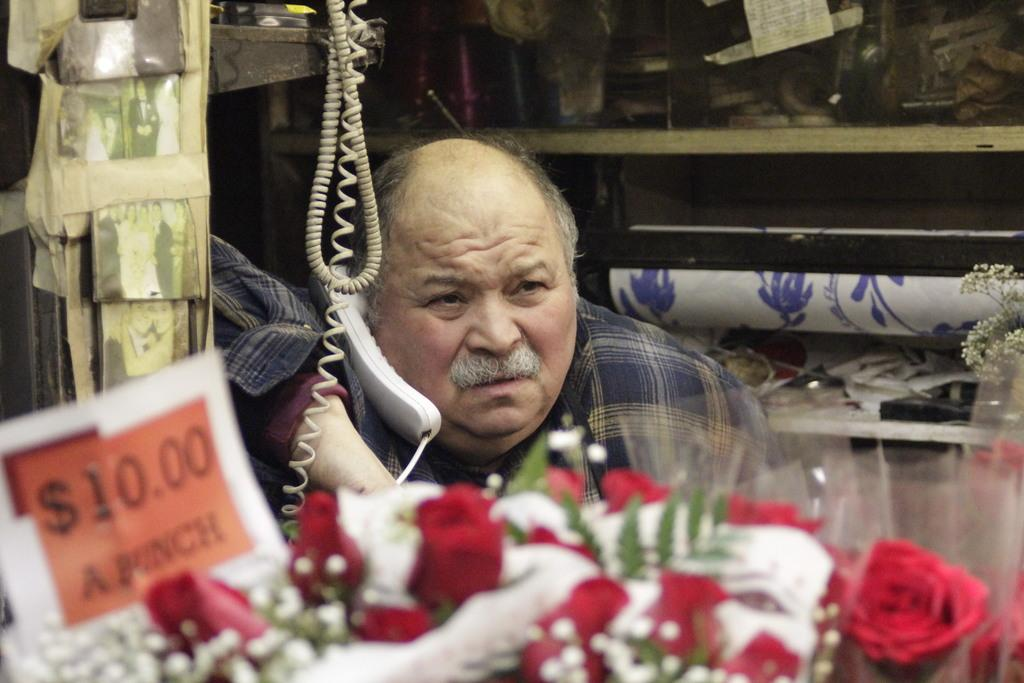What is the person in the image doing with the telephone receiver? The person is holding a telephone receiver near their ear. What can be seen in front of the person? There are wires and flowers in front of the person. Is there any indication of the cost of the items in the image? Yes, there is a price tag in front of the person. What is the nature of the objects in the image? The objects are part of a picture. Can you describe the contents of the racks in the image? Unfortunately, the facts provided do not mention any racks or their contents. Where is the brother of the person in the image standing? There is no mention of a brother in the image, so we cannot answer a question about their location. What type of drug is being sold in the image? There is no indication of any drug being sold or present in the image. 